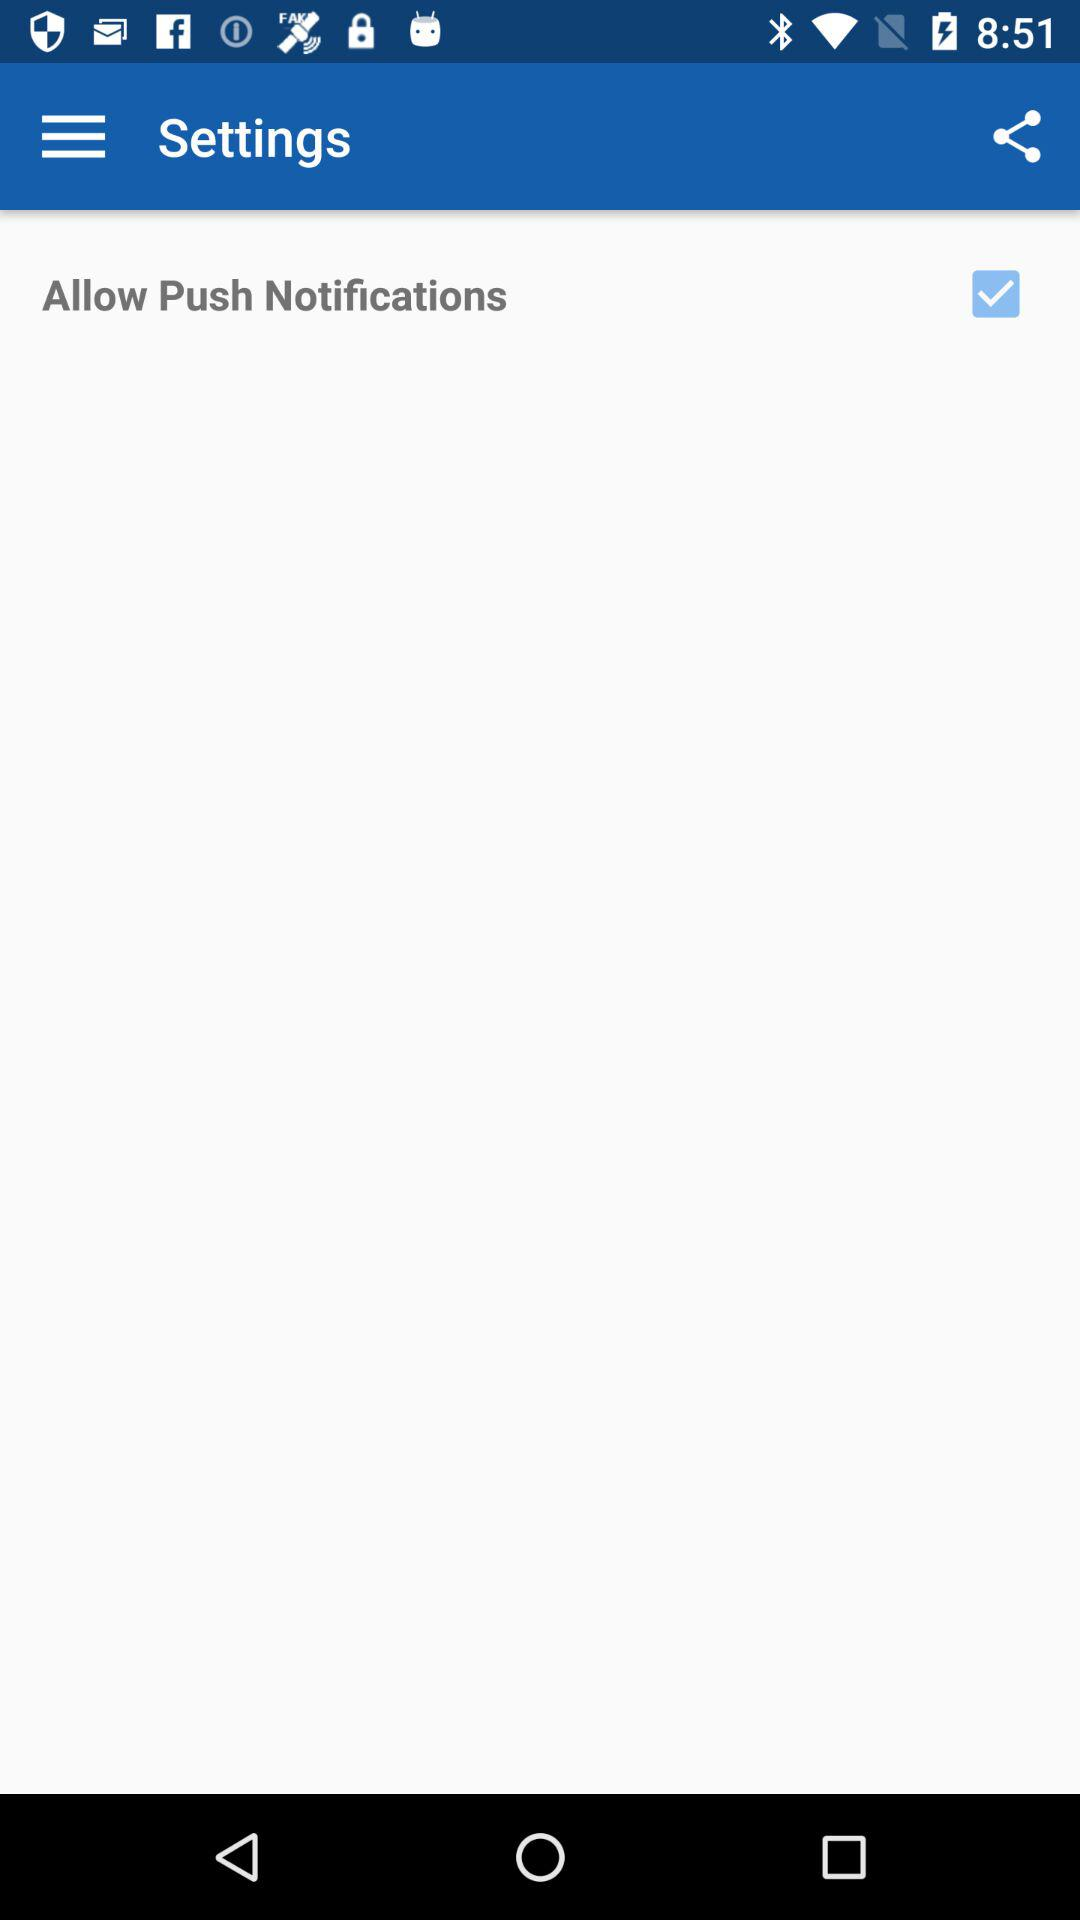What checkbox is checked? The checked checkbox is "Allow Push Notifications". 